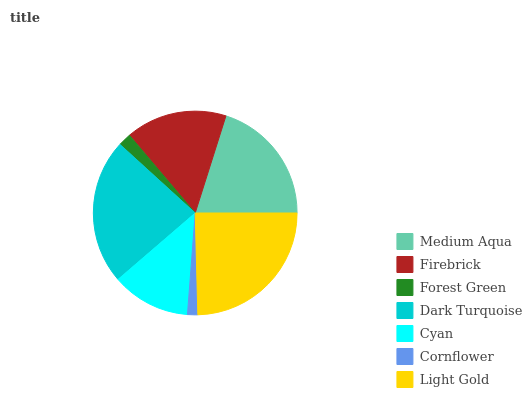Is Cornflower the minimum?
Answer yes or no. Yes. Is Light Gold the maximum?
Answer yes or no. Yes. Is Firebrick the minimum?
Answer yes or no. No. Is Firebrick the maximum?
Answer yes or no. No. Is Medium Aqua greater than Firebrick?
Answer yes or no. Yes. Is Firebrick less than Medium Aqua?
Answer yes or no. Yes. Is Firebrick greater than Medium Aqua?
Answer yes or no. No. Is Medium Aqua less than Firebrick?
Answer yes or no. No. Is Firebrick the high median?
Answer yes or no. Yes. Is Firebrick the low median?
Answer yes or no. Yes. Is Cyan the high median?
Answer yes or no. No. Is Medium Aqua the low median?
Answer yes or no. No. 